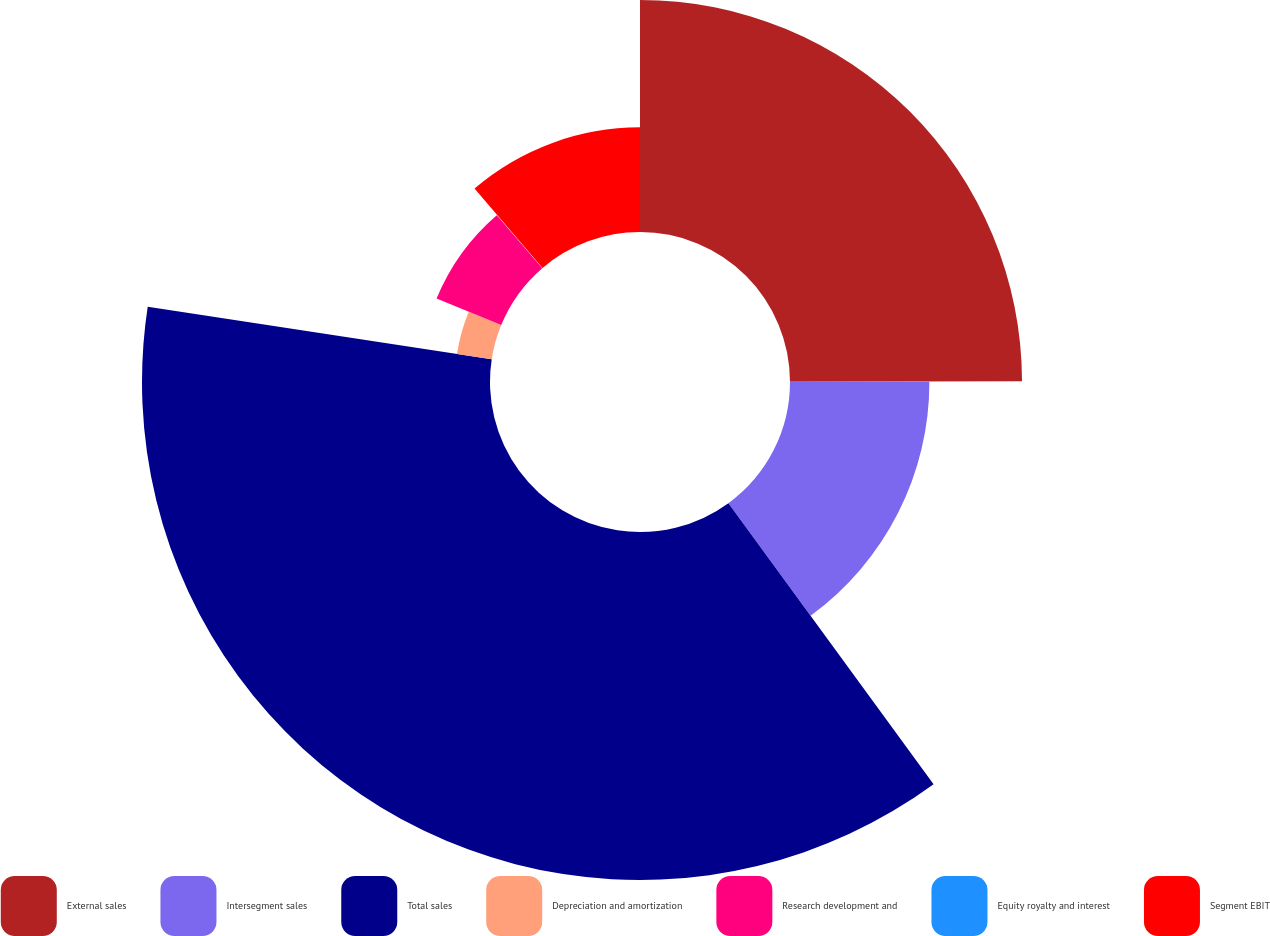Convert chart to OTSL. <chart><loc_0><loc_0><loc_500><loc_500><pie_chart><fcel>External sales<fcel>Intersegment sales<fcel>Total sales<fcel>Depreciation and amortization<fcel>Research development and<fcel>Equity royalty and interest<fcel>Segment EBIT<nl><fcel>24.97%<fcel>15.0%<fcel>37.45%<fcel>3.78%<fcel>7.52%<fcel>0.03%<fcel>11.26%<nl></chart> 